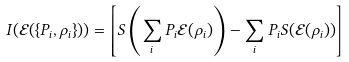<formula> <loc_0><loc_0><loc_500><loc_500>I ( \mathcal { E } ( \{ P _ { i } , \rho _ { i } \} ) ) = \left [ S \left ( \sum _ { i } P _ { i } \mathcal { E } ( \rho _ { i } ) \right ) - \sum _ { i } P _ { i } S ( \mathcal { E } ( \rho _ { i } ) ) \right ]</formula> 